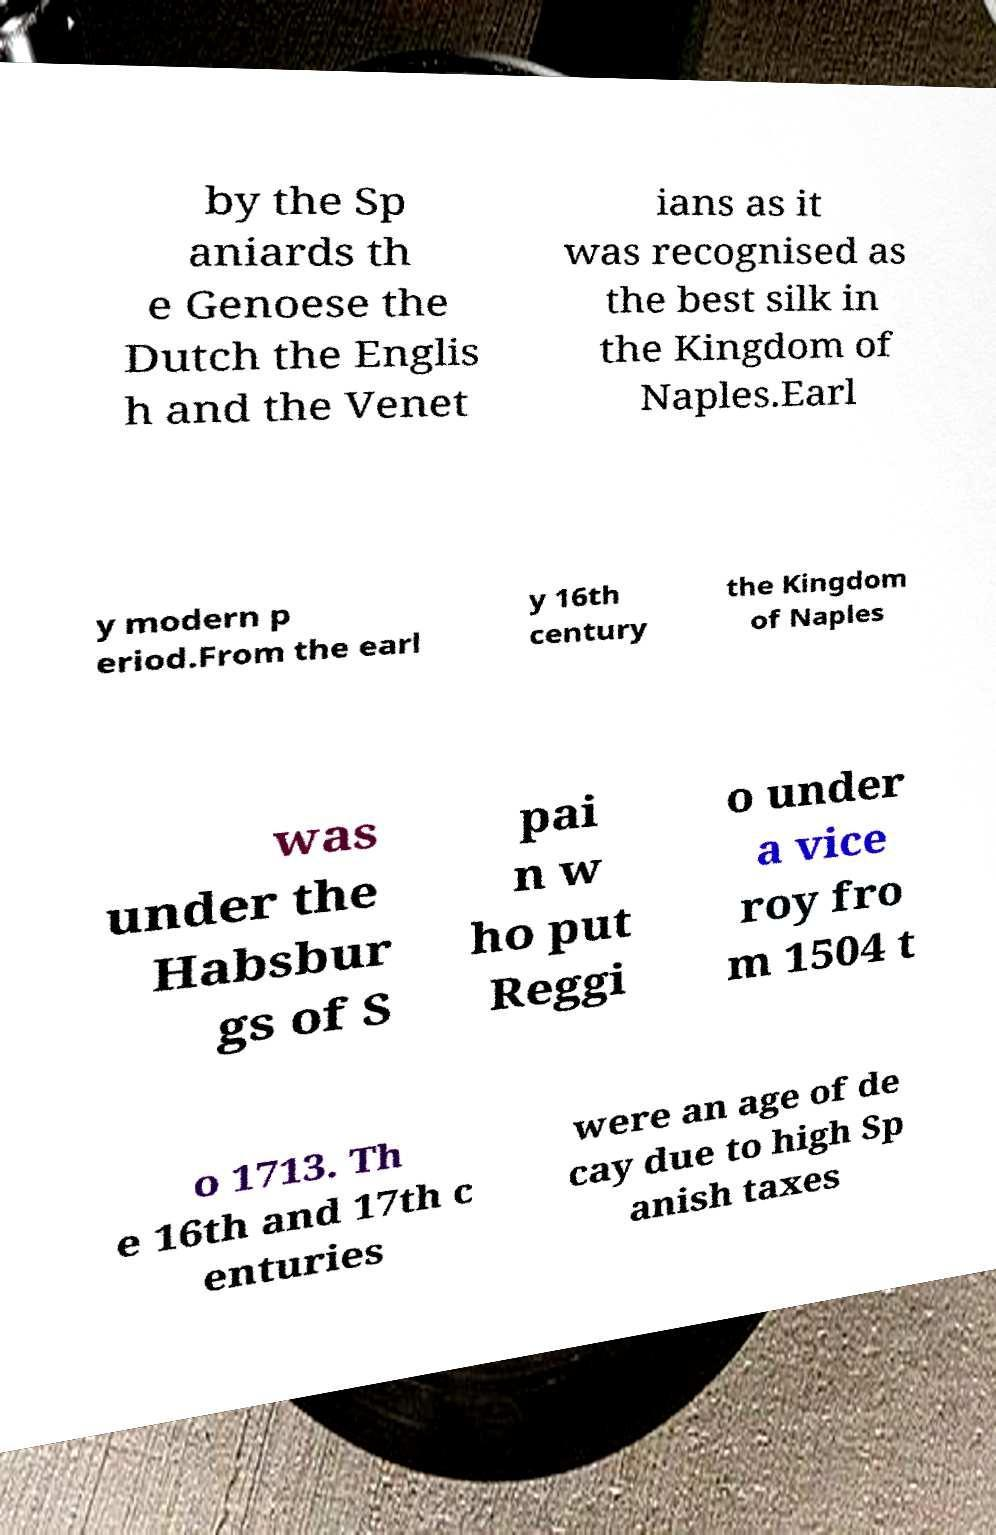Please identify and transcribe the text found in this image. by the Sp aniards th e Genoese the Dutch the Englis h and the Venet ians as it was recognised as the best silk in the Kingdom of Naples.Earl y modern p eriod.From the earl y 16th century the Kingdom of Naples was under the Habsbur gs of S pai n w ho put Reggi o under a vice roy fro m 1504 t o 1713. Th e 16th and 17th c enturies were an age of de cay due to high Sp anish taxes 